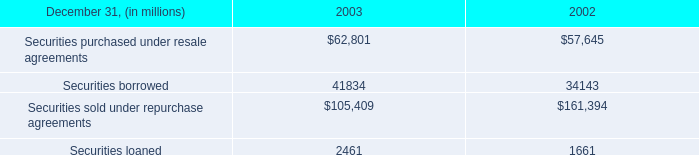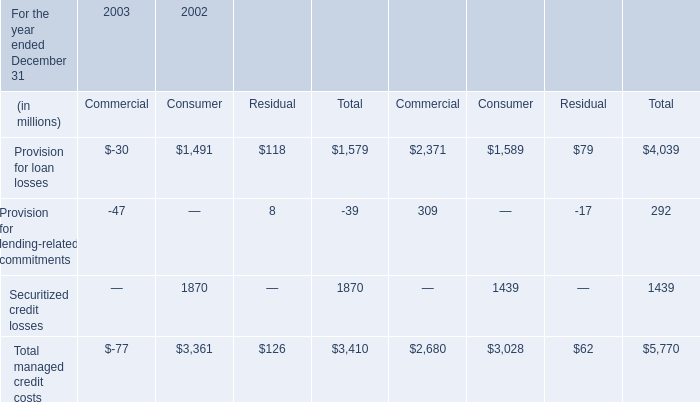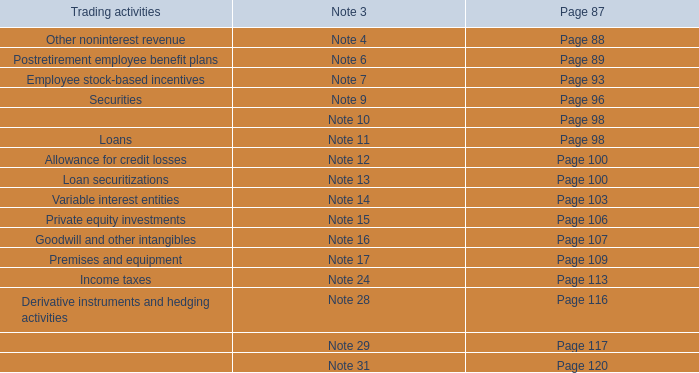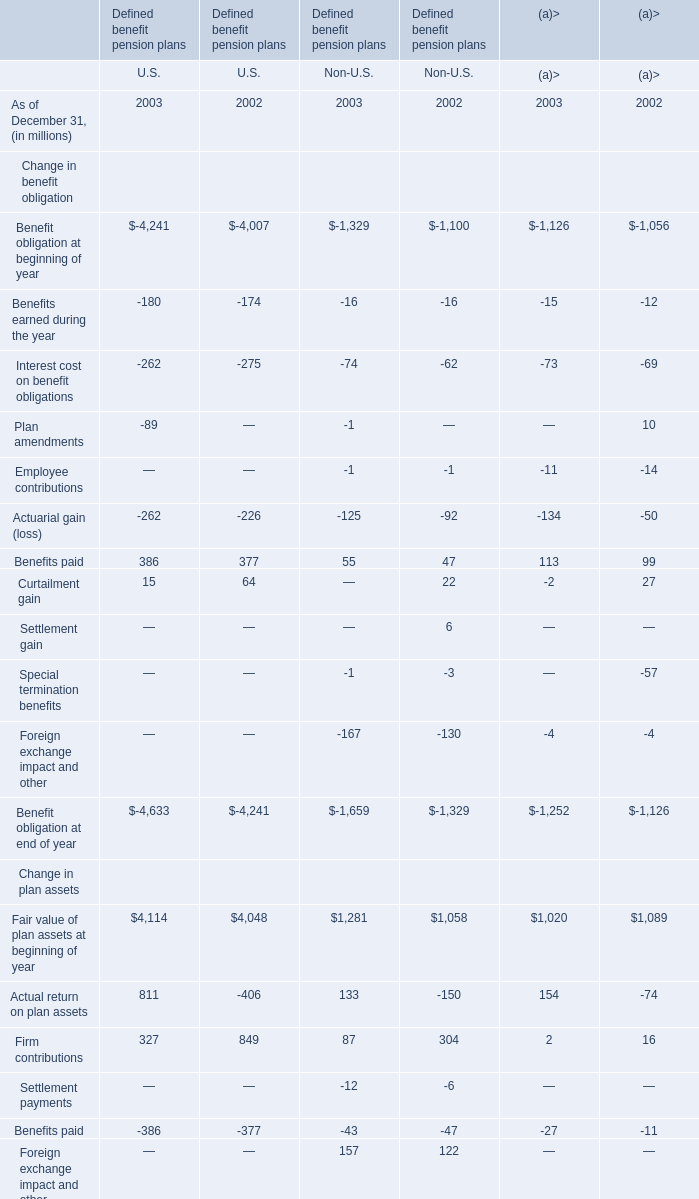what's the total amount of Securities borrowed of 2003, and Provision for loan losses of 2002 Commercial ? 
Computations: (41834.0 + 2371.0)
Answer: 44205.0. 